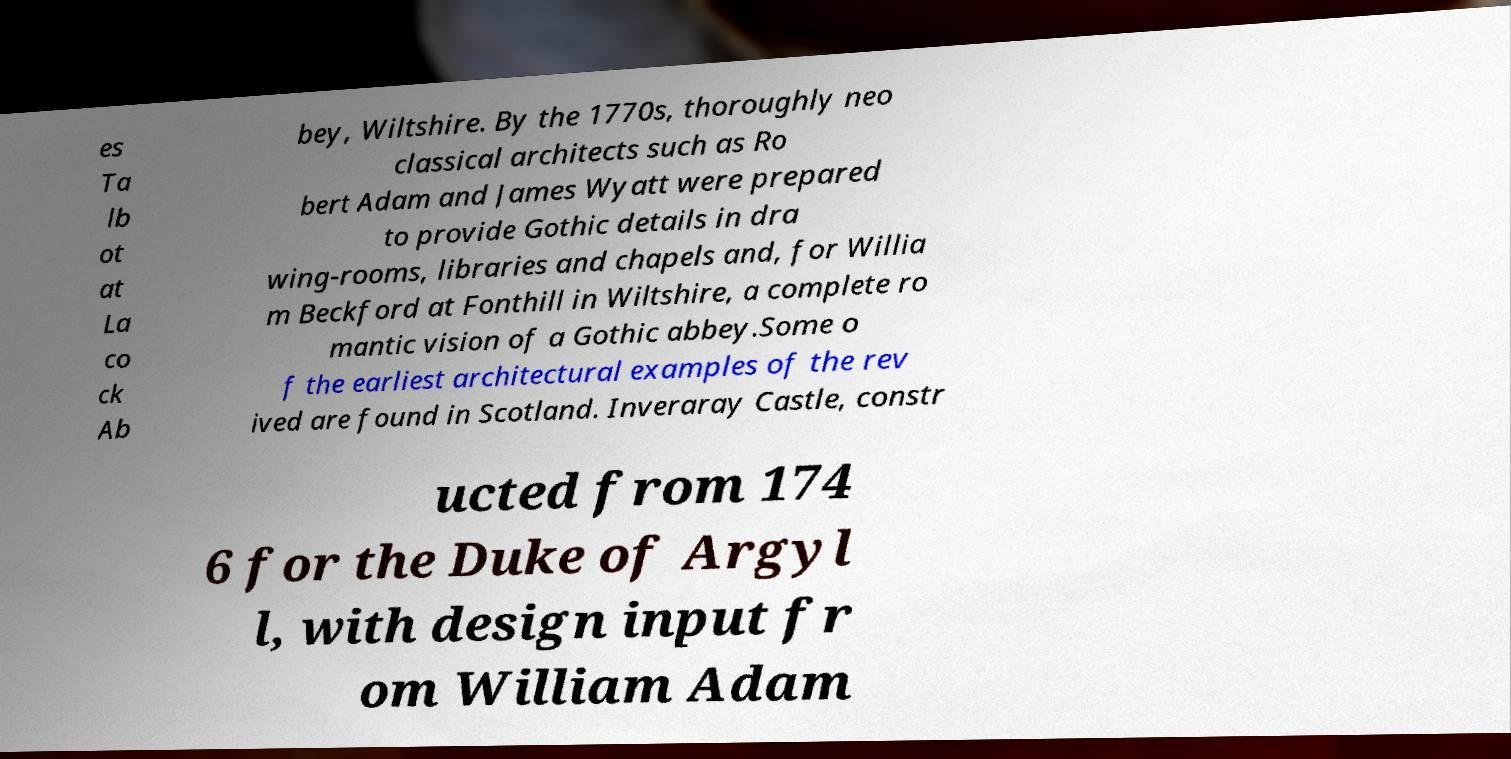Please identify and transcribe the text found in this image. es Ta lb ot at La co ck Ab bey, Wiltshire. By the 1770s, thoroughly neo classical architects such as Ro bert Adam and James Wyatt were prepared to provide Gothic details in dra wing-rooms, libraries and chapels and, for Willia m Beckford at Fonthill in Wiltshire, a complete ro mantic vision of a Gothic abbey.Some o f the earliest architectural examples of the rev ived are found in Scotland. Inveraray Castle, constr ucted from 174 6 for the Duke of Argyl l, with design input fr om William Adam 